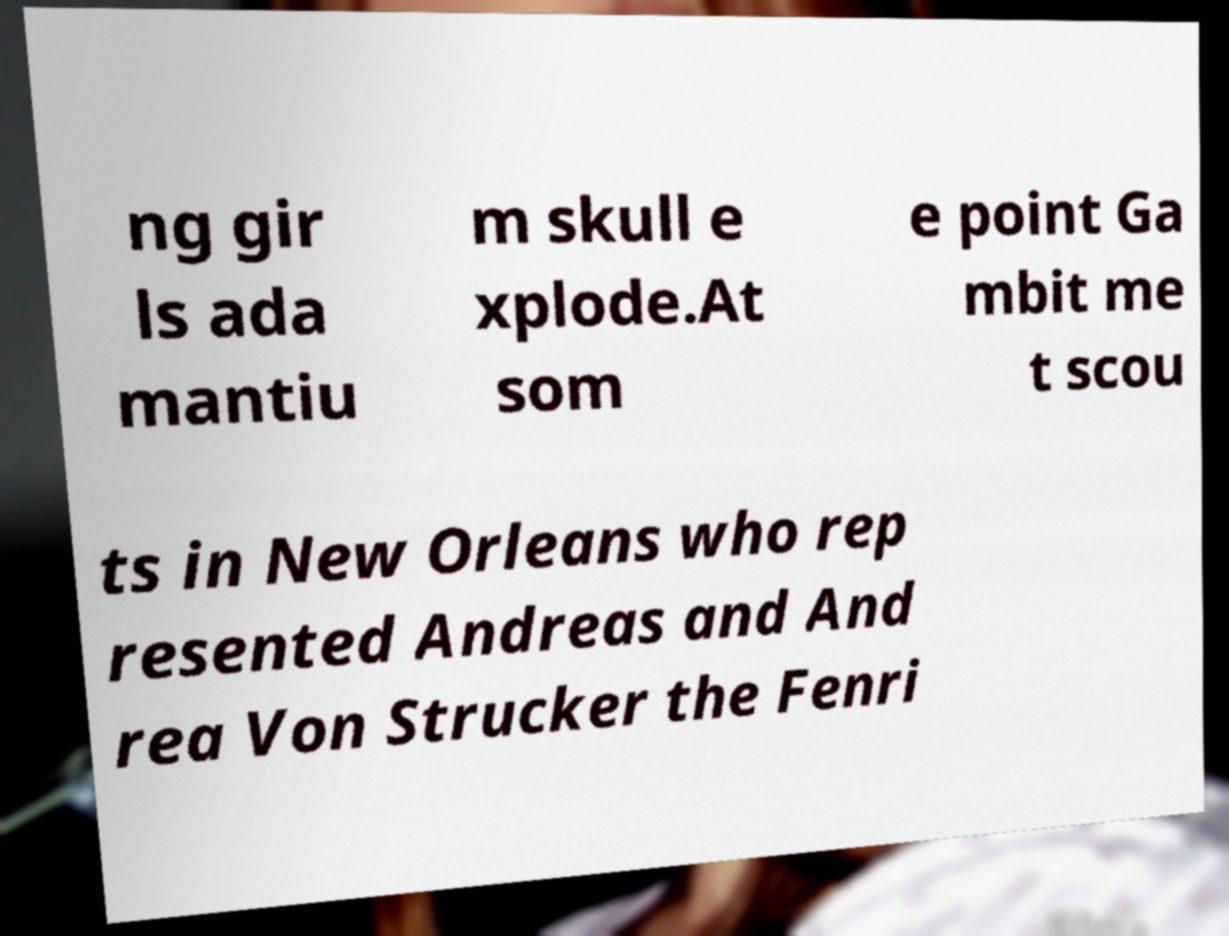There's text embedded in this image that I need extracted. Can you transcribe it verbatim? ng gir ls ada mantiu m skull e xplode.At som e point Ga mbit me t scou ts in New Orleans who rep resented Andreas and And rea Von Strucker the Fenri 